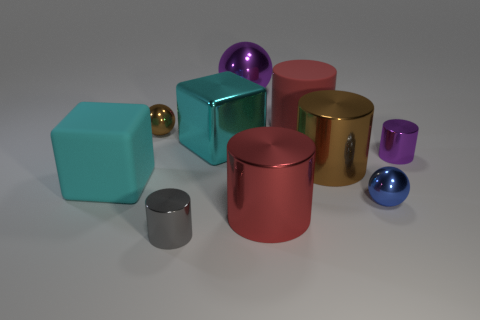Subtract all large matte cylinders. How many cylinders are left? 4 Subtract all red cylinders. How many cylinders are left? 3 Subtract 4 cylinders. How many cylinders are left? 1 Subtract all red spheres. Subtract all red blocks. How many spheres are left? 3 Subtract all green cubes. How many cyan cylinders are left? 0 Subtract all small cylinders. Subtract all small balls. How many objects are left? 6 Add 4 tiny gray shiny cylinders. How many tiny gray shiny cylinders are left? 5 Add 4 large metallic objects. How many large metallic objects exist? 8 Subtract 1 purple spheres. How many objects are left? 9 Subtract all balls. How many objects are left? 7 